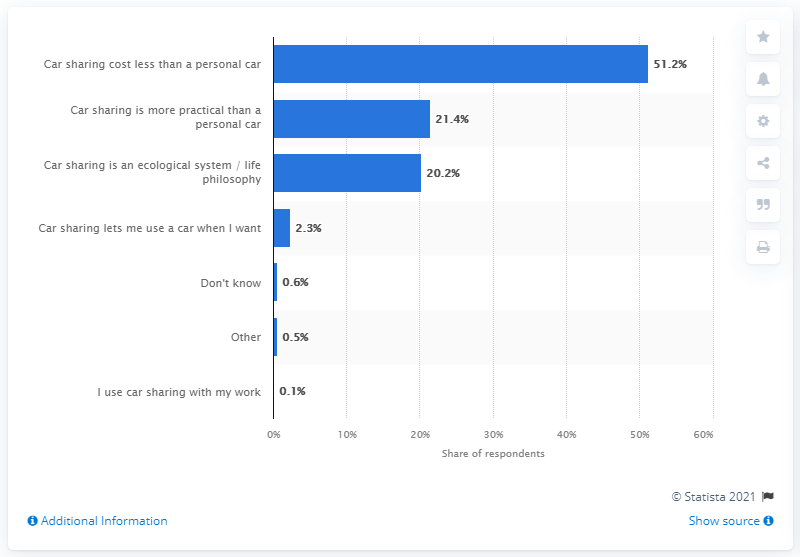Highlight a few significant elements in this photo. According to the data, 2.3% of respondents reported that flexibility was the primary reason for using car sharing services. 